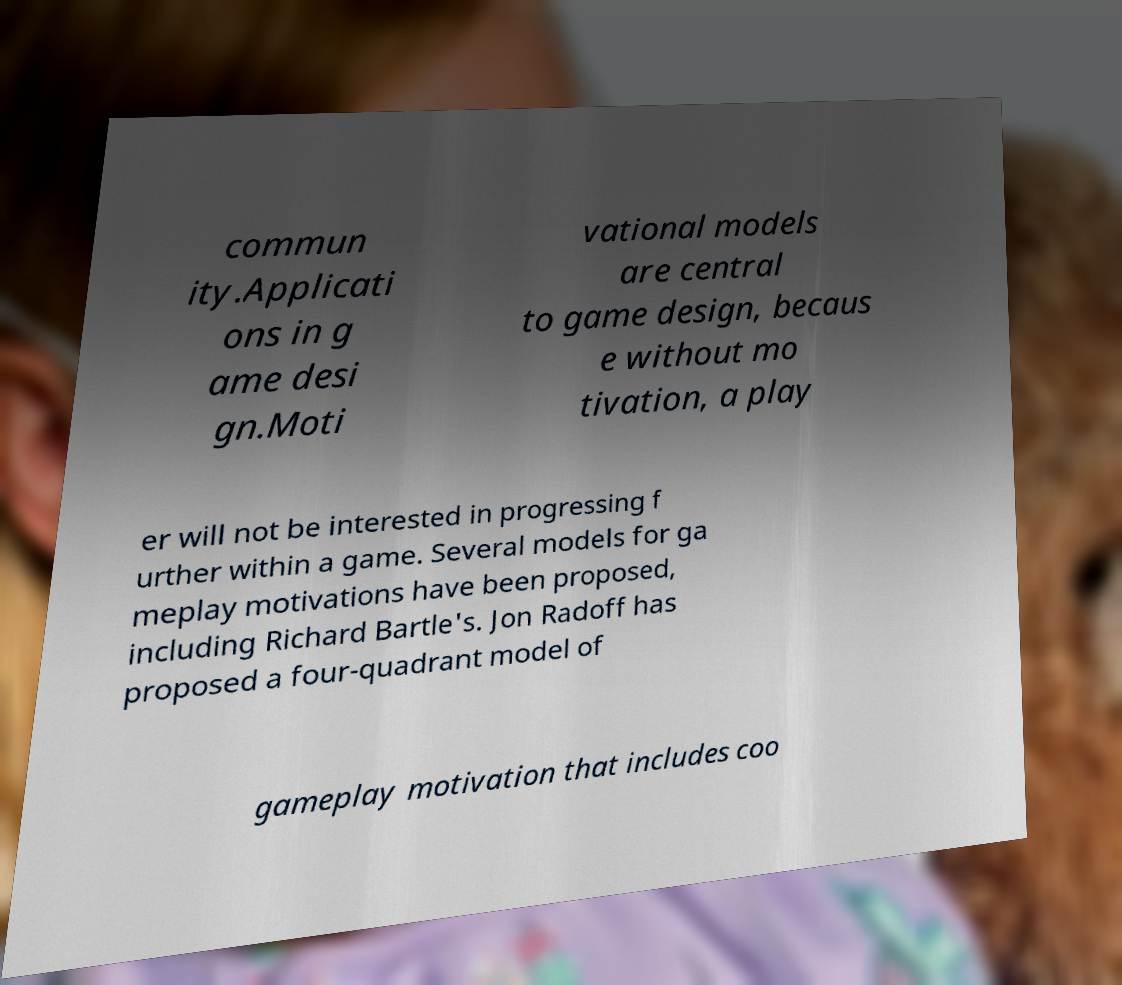What messages or text are displayed in this image? I need them in a readable, typed format. commun ity.Applicati ons in g ame desi gn.Moti vational models are central to game design, becaus e without mo tivation, a play er will not be interested in progressing f urther within a game. Several models for ga meplay motivations have been proposed, including Richard Bartle's. Jon Radoff has proposed a four-quadrant model of gameplay motivation that includes coo 